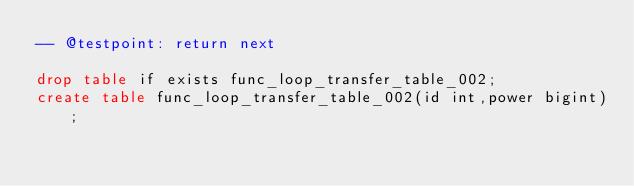<code> <loc_0><loc_0><loc_500><loc_500><_SQL_>-- @testpoint: return next

drop table if exists func_loop_transfer_table_002;
create table func_loop_transfer_table_002(id int,power bigint);</code> 